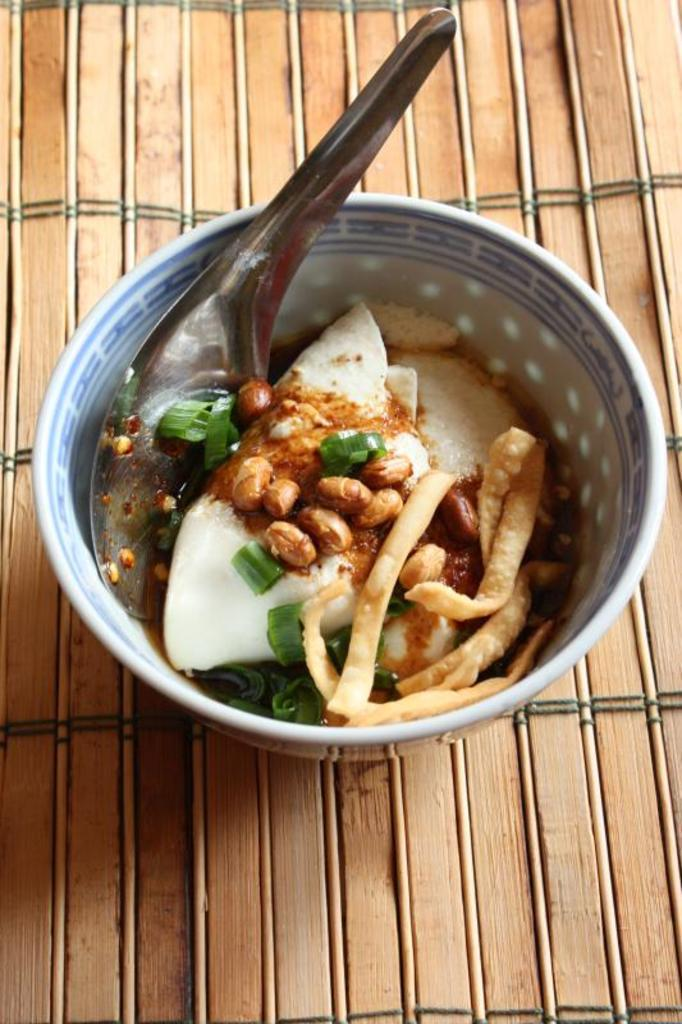What is in the bowl that is visible in the image? There is a bowl with food in the image. What utensil is inside the bowl? There is a spoon inside the bowl. How does the mother open the gate in the image? There is no mother or gate present in the image; it only features a bowl with food and a spoon inside it. 